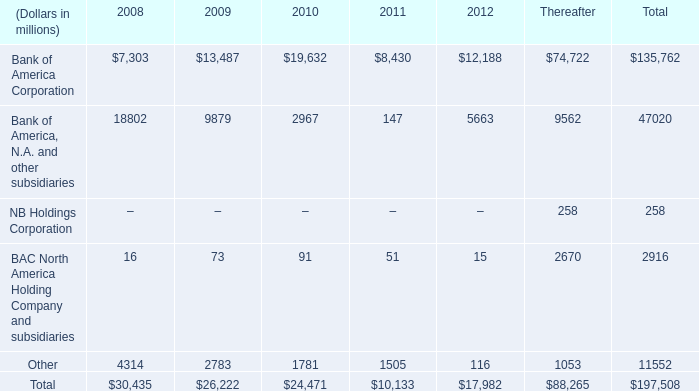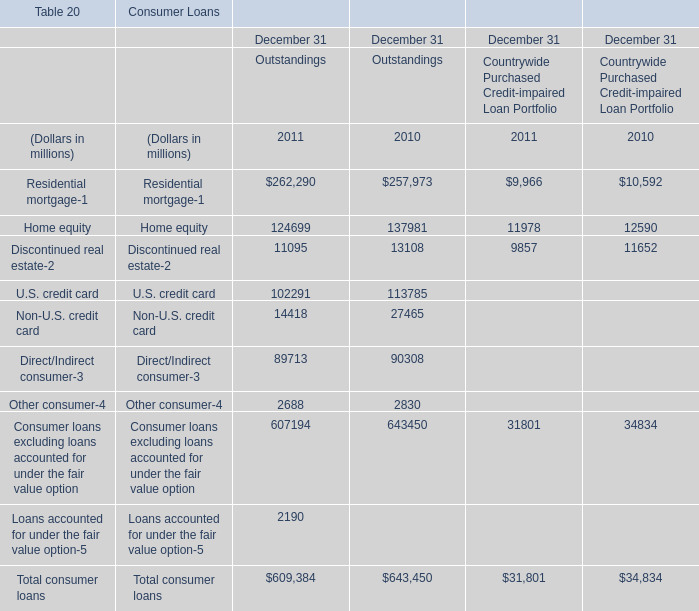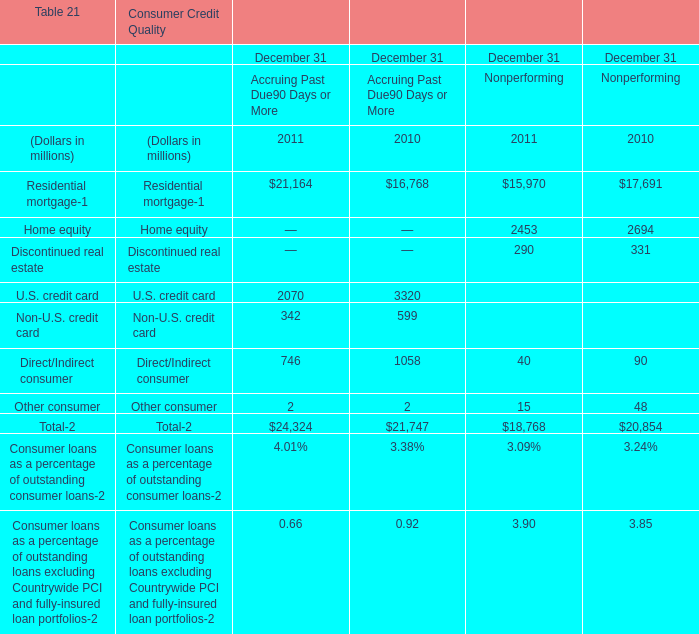Which element has the second largest number in 2011 for Outstandings 
Answer: Consumer loans excluding loans accounted for under the fair value option. 